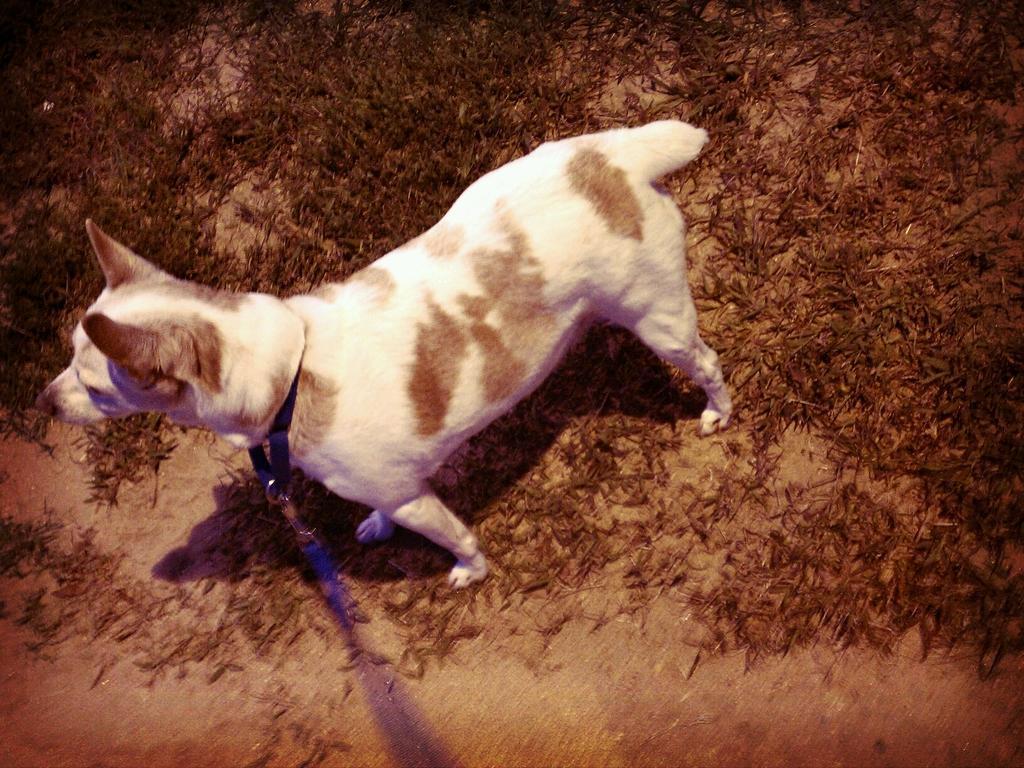How would you summarize this image in a sentence or two? In this image I can see dog which is in white and brown color. Background I can see grass. 